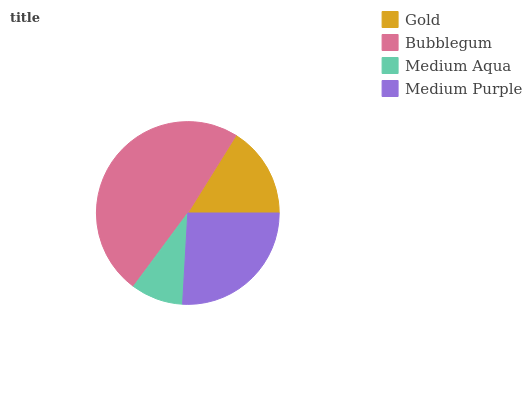Is Medium Aqua the minimum?
Answer yes or no. Yes. Is Bubblegum the maximum?
Answer yes or no. Yes. Is Bubblegum the minimum?
Answer yes or no. No. Is Medium Aqua the maximum?
Answer yes or no. No. Is Bubblegum greater than Medium Aqua?
Answer yes or no. Yes. Is Medium Aqua less than Bubblegum?
Answer yes or no. Yes. Is Medium Aqua greater than Bubblegum?
Answer yes or no. No. Is Bubblegum less than Medium Aqua?
Answer yes or no. No. Is Medium Purple the high median?
Answer yes or no. Yes. Is Gold the low median?
Answer yes or no. Yes. Is Medium Aqua the high median?
Answer yes or no. No. Is Medium Aqua the low median?
Answer yes or no. No. 